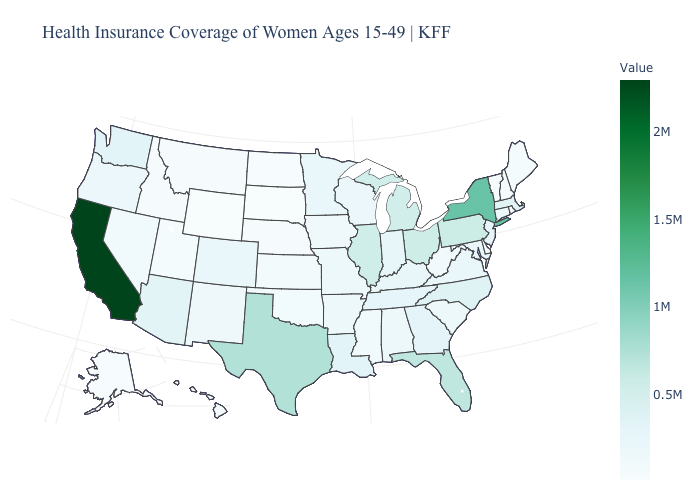Does California have the highest value in the USA?
Keep it brief. Yes. Among the states that border Arizona , does New Mexico have the highest value?
Answer briefly. No. 